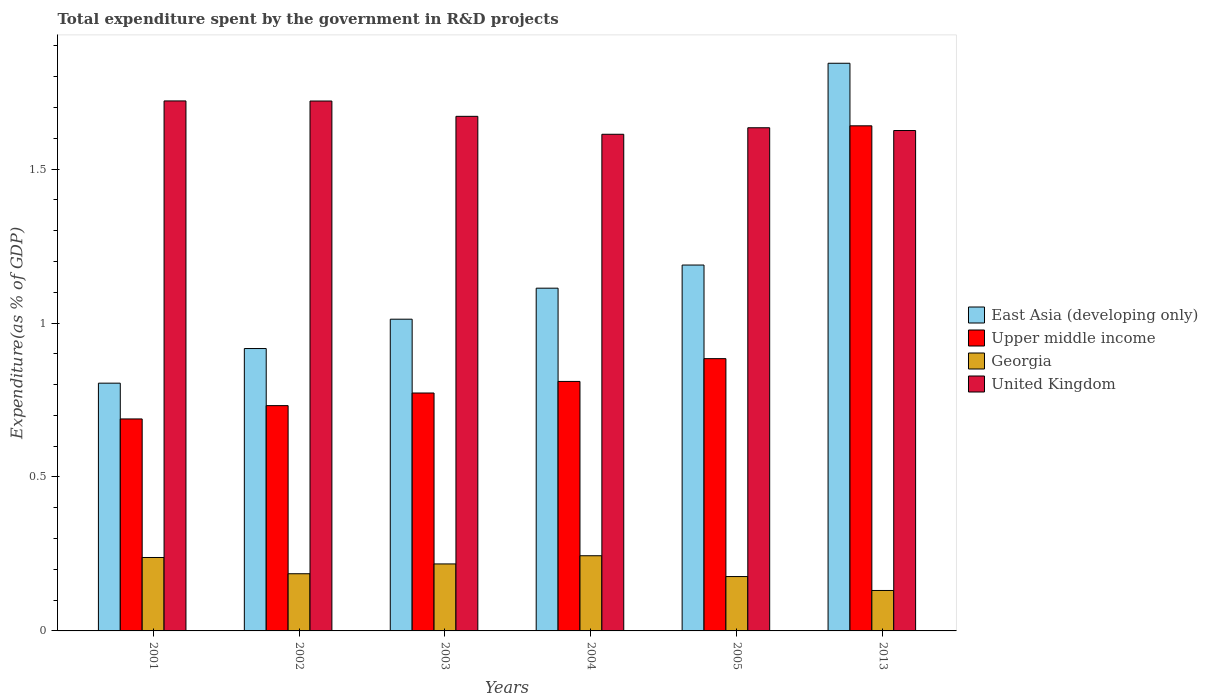How many different coloured bars are there?
Give a very brief answer. 4. How many groups of bars are there?
Keep it short and to the point. 6. Are the number of bars per tick equal to the number of legend labels?
Offer a terse response. Yes. Are the number of bars on each tick of the X-axis equal?
Provide a short and direct response. Yes. How many bars are there on the 4th tick from the left?
Provide a short and direct response. 4. How many bars are there on the 2nd tick from the right?
Offer a terse response. 4. What is the label of the 3rd group of bars from the left?
Your response must be concise. 2003. What is the total expenditure spent by the government in R&D projects in East Asia (developing only) in 2005?
Your response must be concise. 1.19. Across all years, what is the maximum total expenditure spent by the government in R&D projects in United Kingdom?
Your answer should be compact. 1.72. Across all years, what is the minimum total expenditure spent by the government in R&D projects in Upper middle income?
Offer a very short reply. 0.69. In which year was the total expenditure spent by the government in R&D projects in East Asia (developing only) minimum?
Your answer should be very brief. 2001. What is the total total expenditure spent by the government in R&D projects in East Asia (developing only) in the graph?
Offer a very short reply. 6.88. What is the difference between the total expenditure spent by the government in R&D projects in United Kingdom in 2003 and that in 2013?
Your answer should be compact. 0.05. What is the difference between the total expenditure spent by the government in R&D projects in Georgia in 2003 and the total expenditure spent by the government in R&D projects in United Kingdom in 2001?
Offer a very short reply. -1.5. What is the average total expenditure spent by the government in R&D projects in East Asia (developing only) per year?
Ensure brevity in your answer.  1.15. In the year 2004, what is the difference between the total expenditure spent by the government in R&D projects in United Kingdom and total expenditure spent by the government in R&D projects in East Asia (developing only)?
Offer a terse response. 0.5. In how many years, is the total expenditure spent by the government in R&D projects in Georgia greater than 1.4 %?
Ensure brevity in your answer.  0. What is the ratio of the total expenditure spent by the government in R&D projects in United Kingdom in 2003 to that in 2013?
Keep it short and to the point. 1.03. Is the total expenditure spent by the government in R&D projects in Upper middle income in 2001 less than that in 2003?
Offer a very short reply. Yes. What is the difference between the highest and the second highest total expenditure spent by the government in R&D projects in Georgia?
Provide a short and direct response. 0.01. What is the difference between the highest and the lowest total expenditure spent by the government in R&D projects in Upper middle income?
Make the answer very short. 0.95. In how many years, is the total expenditure spent by the government in R&D projects in Georgia greater than the average total expenditure spent by the government in R&D projects in Georgia taken over all years?
Provide a succinct answer. 3. What does the 2nd bar from the left in 2013 represents?
Your answer should be very brief. Upper middle income. What does the 4th bar from the right in 2013 represents?
Provide a succinct answer. East Asia (developing only). Is it the case that in every year, the sum of the total expenditure spent by the government in R&D projects in Georgia and total expenditure spent by the government in R&D projects in East Asia (developing only) is greater than the total expenditure spent by the government in R&D projects in United Kingdom?
Offer a terse response. No. How many bars are there?
Your answer should be compact. 24. Are all the bars in the graph horizontal?
Ensure brevity in your answer.  No. How many years are there in the graph?
Keep it short and to the point. 6. What is the difference between two consecutive major ticks on the Y-axis?
Offer a terse response. 0.5. Does the graph contain any zero values?
Provide a short and direct response. No. Does the graph contain grids?
Provide a succinct answer. No. How many legend labels are there?
Provide a short and direct response. 4. How are the legend labels stacked?
Your answer should be compact. Vertical. What is the title of the graph?
Your answer should be compact. Total expenditure spent by the government in R&D projects. Does "Tonga" appear as one of the legend labels in the graph?
Your response must be concise. No. What is the label or title of the Y-axis?
Provide a succinct answer. Expenditure(as % of GDP). What is the Expenditure(as % of GDP) of East Asia (developing only) in 2001?
Your response must be concise. 0.8. What is the Expenditure(as % of GDP) in Upper middle income in 2001?
Ensure brevity in your answer.  0.69. What is the Expenditure(as % of GDP) of Georgia in 2001?
Offer a very short reply. 0.24. What is the Expenditure(as % of GDP) of United Kingdom in 2001?
Give a very brief answer. 1.72. What is the Expenditure(as % of GDP) of East Asia (developing only) in 2002?
Give a very brief answer. 0.92. What is the Expenditure(as % of GDP) of Upper middle income in 2002?
Provide a succinct answer. 0.73. What is the Expenditure(as % of GDP) of Georgia in 2002?
Provide a short and direct response. 0.19. What is the Expenditure(as % of GDP) in United Kingdom in 2002?
Provide a succinct answer. 1.72. What is the Expenditure(as % of GDP) in East Asia (developing only) in 2003?
Offer a terse response. 1.01. What is the Expenditure(as % of GDP) in Upper middle income in 2003?
Offer a terse response. 0.77. What is the Expenditure(as % of GDP) of Georgia in 2003?
Your answer should be compact. 0.22. What is the Expenditure(as % of GDP) in United Kingdom in 2003?
Keep it short and to the point. 1.67. What is the Expenditure(as % of GDP) in East Asia (developing only) in 2004?
Keep it short and to the point. 1.11. What is the Expenditure(as % of GDP) in Upper middle income in 2004?
Your answer should be very brief. 0.81. What is the Expenditure(as % of GDP) of Georgia in 2004?
Provide a short and direct response. 0.24. What is the Expenditure(as % of GDP) of United Kingdom in 2004?
Keep it short and to the point. 1.61. What is the Expenditure(as % of GDP) of East Asia (developing only) in 2005?
Offer a very short reply. 1.19. What is the Expenditure(as % of GDP) of Upper middle income in 2005?
Provide a short and direct response. 0.88. What is the Expenditure(as % of GDP) of Georgia in 2005?
Ensure brevity in your answer.  0.18. What is the Expenditure(as % of GDP) in United Kingdom in 2005?
Keep it short and to the point. 1.63. What is the Expenditure(as % of GDP) in East Asia (developing only) in 2013?
Ensure brevity in your answer.  1.84. What is the Expenditure(as % of GDP) of Upper middle income in 2013?
Offer a terse response. 1.64. What is the Expenditure(as % of GDP) of Georgia in 2013?
Your answer should be very brief. 0.13. What is the Expenditure(as % of GDP) of United Kingdom in 2013?
Make the answer very short. 1.63. Across all years, what is the maximum Expenditure(as % of GDP) in East Asia (developing only)?
Your response must be concise. 1.84. Across all years, what is the maximum Expenditure(as % of GDP) of Upper middle income?
Provide a short and direct response. 1.64. Across all years, what is the maximum Expenditure(as % of GDP) in Georgia?
Your answer should be compact. 0.24. Across all years, what is the maximum Expenditure(as % of GDP) of United Kingdom?
Make the answer very short. 1.72. Across all years, what is the minimum Expenditure(as % of GDP) of East Asia (developing only)?
Provide a short and direct response. 0.8. Across all years, what is the minimum Expenditure(as % of GDP) of Upper middle income?
Your response must be concise. 0.69. Across all years, what is the minimum Expenditure(as % of GDP) of Georgia?
Make the answer very short. 0.13. Across all years, what is the minimum Expenditure(as % of GDP) of United Kingdom?
Your answer should be very brief. 1.61. What is the total Expenditure(as % of GDP) of East Asia (developing only) in the graph?
Provide a succinct answer. 6.88. What is the total Expenditure(as % of GDP) in Upper middle income in the graph?
Your answer should be compact. 5.53. What is the total Expenditure(as % of GDP) of Georgia in the graph?
Give a very brief answer. 1.19. What is the total Expenditure(as % of GDP) of United Kingdom in the graph?
Keep it short and to the point. 9.99. What is the difference between the Expenditure(as % of GDP) of East Asia (developing only) in 2001 and that in 2002?
Provide a short and direct response. -0.11. What is the difference between the Expenditure(as % of GDP) in Upper middle income in 2001 and that in 2002?
Offer a very short reply. -0.04. What is the difference between the Expenditure(as % of GDP) in Georgia in 2001 and that in 2002?
Offer a terse response. 0.05. What is the difference between the Expenditure(as % of GDP) of United Kingdom in 2001 and that in 2002?
Ensure brevity in your answer.  0. What is the difference between the Expenditure(as % of GDP) in East Asia (developing only) in 2001 and that in 2003?
Offer a very short reply. -0.21. What is the difference between the Expenditure(as % of GDP) in Upper middle income in 2001 and that in 2003?
Provide a succinct answer. -0.08. What is the difference between the Expenditure(as % of GDP) of Georgia in 2001 and that in 2003?
Offer a very short reply. 0.02. What is the difference between the Expenditure(as % of GDP) of East Asia (developing only) in 2001 and that in 2004?
Ensure brevity in your answer.  -0.31. What is the difference between the Expenditure(as % of GDP) in Upper middle income in 2001 and that in 2004?
Keep it short and to the point. -0.12. What is the difference between the Expenditure(as % of GDP) of Georgia in 2001 and that in 2004?
Your answer should be compact. -0.01. What is the difference between the Expenditure(as % of GDP) of United Kingdom in 2001 and that in 2004?
Offer a very short reply. 0.11. What is the difference between the Expenditure(as % of GDP) of East Asia (developing only) in 2001 and that in 2005?
Offer a very short reply. -0.38. What is the difference between the Expenditure(as % of GDP) of Upper middle income in 2001 and that in 2005?
Offer a terse response. -0.2. What is the difference between the Expenditure(as % of GDP) in Georgia in 2001 and that in 2005?
Ensure brevity in your answer.  0.06. What is the difference between the Expenditure(as % of GDP) of United Kingdom in 2001 and that in 2005?
Provide a short and direct response. 0.09. What is the difference between the Expenditure(as % of GDP) in East Asia (developing only) in 2001 and that in 2013?
Offer a very short reply. -1.04. What is the difference between the Expenditure(as % of GDP) of Upper middle income in 2001 and that in 2013?
Offer a very short reply. -0.95. What is the difference between the Expenditure(as % of GDP) in Georgia in 2001 and that in 2013?
Provide a short and direct response. 0.11. What is the difference between the Expenditure(as % of GDP) in United Kingdom in 2001 and that in 2013?
Offer a terse response. 0.1. What is the difference between the Expenditure(as % of GDP) of East Asia (developing only) in 2002 and that in 2003?
Keep it short and to the point. -0.1. What is the difference between the Expenditure(as % of GDP) in Upper middle income in 2002 and that in 2003?
Your answer should be very brief. -0.04. What is the difference between the Expenditure(as % of GDP) of Georgia in 2002 and that in 2003?
Provide a short and direct response. -0.03. What is the difference between the Expenditure(as % of GDP) in United Kingdom in 2002 and that in 2003?
Ensure brevity in your answer.  0.05. What is the difference between the Expenditure(as % of GDP) in East Asia (developing only) in 2002 and that in 2004?
Your answer should be very brief. -0.2. What is the difference between the Expenditure(as % of GDP) in Upper middle income in 2002 and that in 2004?
Your answer should be very brief. -0.08. What is the difference between the Expenditure(as % of GDP) of Georgia in 2002 and that in 2004?
Offer a terse response. -0.06. What is the difference between the Expenditure(as % of GDP) in United Kingdom in 2002 and that in 2004?
Your response must be concise. 0.11. What is the difference between the Expenditure(as % of GDP) of East Asia (developing only) in 2002 and that in 2005?
Offer a very short reply. -0.27. What is the difference between the Expenditure(as % of GDP) of Upper middle income in 2002 and that in 2005?
Provide a short and direct response. -0.15. What is the difference between the Expenditure(as % of GDP) of Georgia in 2002 and that in 2005?
Make the answer very short. 0.01. What is the difference between the Expenditure(as % of GDP) of United Kingdom in 2002 and that in 2005?
Offer a very short reply. 0.09. What is the difference between the Expenditure(as % of GDP) of East Asia (developing only) in 2002 and that in 2013?
Give a very brief answer. -0.93. What is the difference between the Expenditure(as % of GDP) of Upper middle income in 2002 and that in 2013?
Offer a very short reply. -0.91. What is the difference between the Expenditure(as % of GDP) in Georgia in 2002 and that in 2013?
Keep it short and to the point. 0.05. What is the difference between the Expenditure(as % of GDP) of United Kingdom in 2002 and that in 2013?
Make the answer very short. 0.1. What is the difference between the Expenditure(as % of GDP) of East Asia (developing only) in 2003 and that in 2004?
Your answer should be compact. -0.1. What is the difference between the Expenditure(as % of GDP) in Upper middle income in 2003 and that in 2004?
Your response must be concise. -0.04. What is the difference between the Expenditure(as % of GDP) in Georgia in 2003 and that in 2004?
Give a very brief answer. -0.03. What is the difference between the Expenditure(as % of GDP) in United Kingdom in 2003 and that in 2004?
Provide a succinct answer. 0.06. What is the difference between the Expenditure(as % of GDP) in East Asia (developing only) in 2003 and that in 2005?
Offer a terse response. -0.18. What is the difference between the Expenditure(as % of GDP) of Upper middle income in 2003 and that in 2005?
Offer a terse response. -0.11. What is the difference between the Expenditure(as % of GDP) in Georgia in 2003 and that in 2005?
Your answer should be very brief. 0.04. What is the difference between the Expenditure(as % of GDP) in United Kingdom in 2003 and that in 2005?
Your answer should be very brief. 0.04. What is the difference between the Expenditure(as % of GDP) of East Asia (developing only) in 2003 and that in 2013?
Offer a very short reply. -0.83. What is the difference between the Expenditure(as % of GDP) in Upper middle income in 2003 and that in 2013?
Provide a succinct answer. -0.87. What is the difference between the Expenditure(as % of GDP) in Georgia in 2003 and that in 2013?
Your response must be concise. 0.09. What is the difference between the Expenditure(as % of GDP) of United Kingdom in 2003 and that in 2013?
Give a very brief answer. 0.05. What is the difference between the Expenditure(as % of GDP) in East Asia (developing only) in 2004 and that in 2005?
Provide a succinct answer. -0.08. What is the difference between the Expenditure(as % of GDP) in Upper middle income in 2004 and that in 2005?
Offer a terse response. -0.07. What is the difference between the Expenditure(as % of GDP) in Georgia in 2004 and that in 2005?
Keep it short and to the point. 0.07. What is the difference between the Expenditure(as % of GDP) in United Kingdom in 2004 and that in 2005?
Offer a terse response. -0.02. What is the difference between the Expenditure(as % of GDP) in East Asia (developing only) in 2004 and that in 2013?
Ensure brevity in your answer.  -0.73. What is the difference between the Expenditure(as % of GDP) of Upper middle income in 2004 and that in 2013?
Your answer should be compact. -0.83. What is the difference between the Expenditure(as % of GDP) of Georgia in 2004 and that in 2013?
Offer a terse response. 0.11. What is the difference between the Expenditure(as % of GDP) in United Kingdom in 2004 and that in 2013?
Keep it short and to the point. -0.01. What is the difference between the Expenditure(as % of GDP) of East Asia (developing only) in 2005 and that in 2013?
Provide a short and direct response. -0.66. What is the difference between the Expenditure(as % of GDP) of Upper middle income in 2005 and that in 2013?
Provide a succinct answer. -0.76. What is the difference between the Expenditure(as % of GDP) of Georgia in 2005 and that in 2013?
Offer a terse response. 0.05. What is the difference between the Expenditure(as % of GDP) of United Kingdom in 2005 and that in 2013?
Keep it short and to the point. 0.01. What is the difference between the Expenditure(as % of GDP) of East Asia (developing only) in 2001 and the Expenditure(as % of GDP) of Upper middle income in 2002?
Your answer should be very brief. 0.07. What is the difference between the Expenditure(as % of GDP) in East Asia (developing only) in 2001 and the Expenditure(as % of GDP) in Georgia in 2002?
Offer a terse response. 0.62. What is the difference between the Expenditure(as % of GDP) in East Asia (developing only) in 2001 and the Expenditure(as % of GDP) in United Kingdom in 2002?
Make the answer very short. -0.92. What is the difference between the Expenditure(as % of GDP) in Upper middle income in 2001 and the Expenditure(as % of GDP) in Georgia in 2002?
Provide a succinct answer. 0.5. What is the difference between the Expenditure(as % of GDP) of Upper middle income in 2001 and the Expenditure(as % of GDP) of United Kingdom in 2002?
Your response must be concise. -1.03. What is the difference between the Expenditure(as % of GDP) in Georgia in 2001 and the Expenditure(as % of GDP) in United Kingdom in 2002?
Keep it short and to the point. -1.48. What is the difference between the Expenditure(as % of GDP) of East Asia (developing only) in 2001 and the Expenditure(as % of GDP) of Upper middle income in 2003?
Offer a terse response. 0.03. What is the difference between the Expenditure(as % of GDP) in East Asia (developing only) in 2001 and the Expenditure(as % of GDP) in Georgia in 2003?
Your answer should be compact. 0.59. What is the difference between the Expenditure(as % of GDP) of East Asia (developing only) in 2001 and the Expenditure(as % of GDP) of United Kingdom in 2003?
Ensure brevity in your answer.  -0.87. What is the difference between the Expenditure(as % of GDP) of Upper middle income in 2001 and the Expenditure(as % of GDP) of Georgia in 2003?
Your answer should be very brief. 0.47. What is the difference between the Expenditure(as % of GDP) of Upper middle income in 2001 and the Expenditure(as % of GDP) of United Kingdom in 2003?
Make the answer very short. -0.98. What is the difference between the Expenditure(as % of GDP) in Georgia in 2001 and the Expenditure(as % of GDP) in United Kingdom in 2003?
Make the answer very short. -1.43. What is the difference between the Expenditure(as % of GDP) of East Asia (developing only) in 2001 and the Expenditure(as % of GDP) of Upper middle income in 2004?
Provide a succinct answer. -0.01. What is the difference between the Expenditure(as % of GDP) in East Asia (developing only) in 2001 and the Expenditure(as % of GDP) in Georgia in 2004?
Keep it short and to the point. 0.56. What is the difference between the Expenditure(as % of GDP) in East Asia (developing only) in 2001 and the Expenditure(as % of GDP) in United Kingdom in 2004?
Your response must be concise. -0.81. What is the difference between the Expenditure(as % of GDP) in Upper middle income in 2001 and the Expenditure(as % of GDP) in Georgia in 2004?
Your response must be concise. 0.44. What is the difference between the Expenditure(as % of GDP) of Upper middle income in 2001 and the Expenditure(as % of GDP) of United Kingdom in 2004?
Your answer should be very brief. -0.92. What is the difference between the Expenditure(as % of GDP) in Georgia in 2001 and the Expenditure(as % of GDP) in United Kingdom in 2004?
Offer a terse response. -1.37. What is the difference between the Expenditure(as % of GDP) in East Asia (developing only) in 2001 and the Expenditure(as % of GDP) in Upper middle income in 2005?
Provide a short and direct response. -0.08. What is the difference between the Expenditure(as % of GDP) in East Asia (developing only) in 2001 and the Expenditure(as % of GDP) in Georgia in 2005?
Give a very brief answer. 0.63. What is the difference between the Expenditure(as % of GDP) in East Asia (developing only) in 2001 and the Expenditure(as % of GDP) in United Kingdom in 2005?
Keep it short and to the point. -0.83. What is the difference between the Expenditure(as % of GDP) in Upper middle income in 2001 and the Expenditure(as % of GDP) in Georgia in 2005?
Provide a succinct answer. 0.51. What is the difference between the Expenditure(as % of GDP) in Upper middle income in 2001 and the Expenditure(as % of GDP) in United Kingdom in 2005?
Your answer should be compact. -0.95. What is the difference between the Expenditure(as % of GDP) of Georgia in 2001 and the Expenditure(as % of GDP) of United Kingdom in 2005?
Your answer should be very brief. -1.4. What is the difference between the Expenditure(as % of GDP) in East Asia (developing only) in 2001 and the Expenditure(as % of GDP) in Upper middle income in 2013?
Your answer should be very brief. -0.84. What is the difference between the Expenditure(as % of GDP) in East Asia (developing only) in 2001 and the Expenditure(as % of GDP) in Georgia in 2013?
Ensure brevity in your answer.  0.67. What is the difference between the Expenditure(as % of GDP) of East Asia (developing only) in 2001 and the Expenditure(as % of GDP) of United Kingdom in 2013?
Provide a short and direct response. -0.82. What is the difference between the Expenditure(as % of GDP) of Upper middle income in 2001 and the Expenditure(as % of GDP) of Georgia in 2013?
Ensure brevity in your answer.  0.56. What is the difference between the Expenditure(as % of GDP) in Upper middle income in 2001 and the Expenditure(as % of GDP) in United Kingdom in 2013?
Your answer should be very brief. -0.94. What is the difference between the Expenditure(as % of GDP) of Georgia in 2001 and the Expenditure(as % of GDP) of United Kingdom in 2013?
Offer a terse response. -1.39. What is the difference between the Expenditure(as % of GDP) of East Asia (developing only) in 2002 and the Expenditure(as % of GDP) of Upper middle income in 2003?
Offer a very short reply. 0.14. What is the difference between the Expenditure(as % of GDP) of East Asia (developing only) in 2002 and the Expenditure(as % of GDP) of Georgia in 2003?
Give a very brief answer. 0.7. What is the difference between the Expenditure(as % of GDP) of East Asia (developing only) in 2002 and the Expenditure(as % of GDP) of United Kingdom in 2003?
Give a very brief answer. -0.75. What is the difference between the Expenditure(as % of GDP) of Upper middle income in 2002 and the Expenditure(as % of GDP) of Georgia in 2003?
Offer a terse response. 0.51. What is the difference between the Expenditure(as % of GDP) of Upper middle income in 2002 and the Expenditure(as % of GDP) of United Kingdom in 2003?
Offer a very short reply. -0.94. What is the difference between the Expenditure(as % of GDP) in Georgia in 2002 and the Expenditure(as % of GDP) in United Kingdom in 2003?
Your answer should be compact. -1.49. What is the difference between the Expenditure(as % of GDP) in East Asia (developing only) in 2002 and the Expenditure(as % of GDP) in Upper middle income in 2004?
Keep it short and to the point. 0.11. What is the difference between the Expenditure(as % of GDP) in East Asia (developing only) in 2002 and the Expenditure(as % of GDP) in Georgia in 2004?
Your answer should be compact. 0.67. What is the difference between the Expenditure(as % of GDP) in East Asia (developing only) in 2002 and the Expenditure(as % of GDP) in United Kingdom in 2004?
Give a very brief answer. -0.7. What is the difference between the Expenditure(as % of GDP) in Upper middle income in 2002 and the Expenditure(as % of GDP) in Georgia in 2004?
Offer a very short reply. 0.49. What is the difference between the Expenditure(as % of GDP) of Upper middle income in 2002 and the Expenditure(as % of GDP) of United Kingdom in 2004?
Offer a very short reply. -0.88. What is the difference between the Expenditure(as % of GDP) in Georgia in 2002 and the Expenditure(as % of GDP) in United Kingdom in 2004?
Your answer should be compact. -1.43. What is the difference between the Expenditure(as % of GDP) in East Asia (developing only) in 2002 and the Expenditure(as % of GDP) in Upper middle income in 2005?
Make the answer very short. 0.03. What is the difference between the Expenditure(as % of GDP) in East Asia (developing only) in 2002 and the Expenditure(as % of GDP) in Georgia in 2005?
Keep it short and to the point. 0.74. What is the difference between the Expenditure(as % of GDP) in East Asia (developing only) in 2002 and the Expenditure(as % of GDP) in United Kingdom in 2005?
Provide a succinct answer. -0.72. What is the difference between the Expenditure(as % of GDP) in Upper middle income in 2002 and the Expenditure(as % of GDP) in Georgia in 2005?
Provide a succinct answer. 0.56. What is the difference between the Expenditure(as % of GDP) in Upper middle income in 2002 and the Expenditure(as % of GDP) in United Kingdom in 2005?
Keep it short and to the point. -0.9. What is the difference between the Expenditure(as % of GDP) in Georgia in 2002 and the Expenditure(as % of GDP) in United Kingdom in 2005?
Your response must be concise. -1.45. What is the difference between the Expenditure(as % of GDP) of East Asia (developing only) in 2002 and the Expenditure(as % of GDP) of Upper middle income in 2013?
Make the answer very short. -0.72. What is the difference between the Expenditure(as % of GDP) in East Asia (developing only) in 2002 and the Expenditure(as % of GDP) in Georgia in 2013?
Make the answer very short. 0.79. What is the difference between the Expenditure(as % of GDP) in East Asia (developing only) in 2002 and the Expenditure(as % of GDP) in United Kingdom in 2013?
Provide a short and direct response. -0.71. What is the difference between the Expenditure(as % of GDP) in Upper middle income in 2002 and the Expenditure(as % of GDP) in Georgia in 2013?
Your answer should be compact. 0.6. What is the difference between the Expenditure(as % of GDP) of Upper middle income in 2002 and the Expenditure(as % of GDP) of United Kingdom in 2013?
Offer a terse response. -0.89. What is the difference between the Expenditure(as % of GDP) in Georgia in 2002 and the Expenditure(as % of GDP) in United Kingdom in 2013?
Make the answer very short. -1.44. What is the difference between the Expenditure(as % of GDP) of East Asia (developing only) in 2003 and the Expenditure(as % of GDP) of Upper middle income in 2004?
Give a very brief answer. 0.2. What is the difference between the Expenditure(as % of GDP) in East Asia (developing only) in 2003 and the Expenditure(as % of GDP) in Georgia in 2004?
Offer a terse response. 0.77. What is the difference between the Expenditure(as % of GDP) of East Asia (developing only) in 2003 and the Expenditure(as % of GDP) of United Kingdom in 2004?
Keep it short and to the point. -0.6. What is the difference between the Expenditure(as % of GDP) of Upper middle income in 2003 and the Expenditure(as % of GDP) of Georgia in 2004?
Offer a very short reply. 0.53. What is the difference between the Expenditure(as % of GDP) of Upper middle income in 2003 and the Expenditure(as % of GDP) of United Kingdom in 2004?
Offer a very short reply. -0.84. What is the difference between the Expenditure(as % of GDP) in Georgia in 2003 and the Expenditure(as % of GDP) in United Kingdom in 2004?
Your answer should be compact. -1.4. What is the difference between the Expenditure(as % of GDP) in East Asia (developing only) in 2003 and the Expenditure(as % of GDP) in Upper middle income in 2005?
Provide a succinct answer. 0.13. What is the difference between the Expenditure(as % of GDP) in East Asia (developing only) in 2003 and the Expenditure(as % of GDP) in Georgia in 2005?
Keep it short and to the point. 0.84. What is the difference between the Expenditure(as % of GDP) in East Asia (developing only) in 2003 and the Expenditure(as % of GDP) in United Kingdom in 2005?
Offer a very short reply. -0.62. What is the difference between the Expenditure(as % of GDP) in Upper middle income in 2003 and the Expenditure(as % of GDP) in Georgia in 2005?
Offer a terse response. 0.6. What is the difference between the Expenditure(as % of GDP) of Upper middle income in 2003 and the Expenditure(as % of GDP) of United Kingdom in 2005?
Ensure brevity in your answer.  -0.86. What is the difference between the Expenditure(as % of GDP) of Georgia in 2003 and the Expenditure(as % of GDP) of United Kingdom in 2005?
Make the answer very short. -1.42. What is the difference between the Expenditure(as % of GDP) of East Asia (developing only) in 2003 and the Expenditure(as % of GDP) of Upper middle income in 2013?
Provide a short and direct response. -0.63. What is the difference between the Expenditure(as % of GDP) in East Asia (developing only) in 2003 and the Expenditure(as % of GDP) in Georgia in 2013?
Provide a short and direct response. 0.88. What is the difference between the Expenditure(as % of GDP) of East Asia (developing only) in 2003 and the Expenditure(as % of GDP) of United Kingdom in 2013?
Provide a short and direct response. -0.61. What is the difference between the Expenditure(as % of GDP) of Upper middle income in 2003 and the Expenditure(as % of GDP) of Georgia in 2013?
Keep it short and to the point. 0.64. What is the difference between the Expenditure(as % of GDP) of Upper middle income in 2003 and the Expenditure(as % of GDP) of United Kingdom in 2013?
Give a very brief answer. -0.85. What is the difference between the Expenditure(as % of GDP) of Georgia in 2003 and the Expenditure(as % of GDP) of United Kingdom in 2013?
Offer a very short reply. -1.41. What is the difference between the Expenditure(as % of GDP) of East Asia (developing only) in 2004 and the Expenditure(as % of GDP) of Upper middle income in 2005?
Your answer should be very brief. 0.23. What is the difference between the Expenditure(as % of GDP) of East Asia (developing only) in 2004 and the Expenditure(as % of GDP) of Georgia in 2005?
Provide a succinct answer. 0.94. What is the difference between the Expenditure(as % of GDP) of East Asia (developing only) in 2004 and the Expenditure(as % of GDP) of United Kingdom in 2005?
Give a very brief answer. -0.52. What is the difference between the Expenditure(as % of GDP) in Upper middle income in 2004 and the Expenditure(as % of GDP) in Georgia in 2005?
Make the answer very short. 0.63. What is the difference between the Expenditure(as % of GDP) of Upper middle income in 2004 and the Expenditure(as % of GDP) of United Kingdom in 2005?
Offer a very short reply. -0.82. What is the difference between the Expenditure(as % of GDP) of Georgia in 2004 and the Expenditure(as % of GDP) of United Kingdom in 2005?
Provide a short and direct response. -1.39. What is the difference between the Expenditure(as % of GDP) in East Asia (developing only) in 2004 and the Expenditure(as % of GDP) in Upper middle income in 2013?
Your answer should be compact. -0.53. What is the difference between the Expenditure(as % of GDP) of East Asia (developing only) in 2004 and the Expenditure(as % of GDP) of Georgia in 2013?
Provide a short and direct response. 0.98. What is the difference between the Expenditure(as % of GDP) in East Asia (developing only) in 2004 and the Expenditure(as % of GDP) in United Kingdom in 2013?
Offer a terse response. -0.51. What is the difference between the Expenditure(as % of GDP) in Upper middle income in 2004 and the Expenditure(as % of GDP) in Georgia in 2013?
Provide a succinct answer. 0.68. What is the difference between the Expenditure(as % of GDP) of Upper middle income in 2004 and the Expenditure(as % of GDP) of United Kingdom in 2013?
Your answer should be compact. -0.81. What is the difference between the Expenditure(as % of GDP) of Georgia in 2004 and the Expenditure(as % of GDP) of United Kingdom in 2013?
Offer a terse response. -1.38. What is the difference between the Expenditure(as % of GDP) of East Asia (developing only) in 2005 and the Expenditure(as % of GDP) of Upper middle income in 2013?
Offer a terse response. -0.45. What is the difference between the Expenditure(as % of GDP) in East Asia (developing only) in 2005 and the Expenditure(as % of GDP) in Georgia in 2013?
Offer a terse response. 1.06. What is the difference between the Expenditure(as % of GDP) of East Asia (developing only) in 2005 and the Expenditure(as % of GDP) of United Kingdom in 2013?
Offer a very short reply. -0.44. What is the difference between the Expenditure(as % of GDP) in Upper middle income in 2005 and the Expenditure(as % of GDP) in Georgia in 2013?
Ensure brevity in your answer.  0.75. What is the difference between the Expenditure(as % of GDP) of Upper middle income in 2005 and the Expenditure(as % of GDP) of United Kingdom in 2013?
Provide a succinct answer. -0.74. What is the difference between the Expenditure(as % of GDP) of Georgia in 2005 and the Expenditure(as % of GDP) of United Kingdom in 2013?
Your response must be concise. -1.45. What is the average Expenditure(as % of GDP) in East Asia (developing only) per year?
Your answer should be compact. 1.15. What is the average Expenditure(as % of GDP) of Upper middle income per year?
Offer a very short reply. 0.92. What is the average Expenditure(as % of GDP) in Georgia per year?
Ensure brevity in your answer.  0.2. What is the average Expenditure(as % of GDP) in United Kingdom per year?
Keep it short and to the point. 1.66. In the year 2001, what is the difference between the Expenditure(as % of GDP) in East Asia (developing only) and Expenditure(as % of GDP) in Upper middle income?
Provide a short and direct response. 0.12. In the year 2001, what is the difference between the Expenditure(as % of GDP) of East Asia (developing only) and Expenditure(as % of GDP) of Georgia?
Make the answer very short. 0.57. In the year 2001, what is the difference between the Expenditure(as % of GDP) of East Asia (developing only) and Expenditure(as % of GDP) of United Kingdom?
Offer a terse response. -0.92. In the year 2001, what is the difference between the Expenditure(as % of GDP) in Upper middle income and Expenditure(as % of GDP) in Georgia?
Your answer should be compact. 0.45. In the year 2001, what is the difference between the Expenditure(as % of GDP) in Upper middle income and Expenditure(as % of GDP) in United Kingdom?
Offer a terse response. -1.03. In the year 2001, what is the difference between the Expenditure(as % of GDP) in Georgia and Expenditure(as % of GDP) in United Kingdom?
Offer a terse response. -1.48. In the year 2002, what is the difference between the Expenditure(as % of GDP) of East Asia (developing only) and Expenditure(as % of GDP) of Upper middle income?
Your answer should be compact. 0.19. In the year 2002, what is the difference between the Expenditure(as % of GDP) of East Asia (developing only) and Expenditure(as % of GDP) of Georgia?
Provide a short and direct response. 0.73. In the year 2002, what is the difference between the Expenditure(as % of GDP) in East Asia (developing only) and Expenditure(as % of GDP) in United Kingdom?
Your answer should be compact. -0.8. In the year 2002, what is the difference between the Expenditure(as % of GDP) in Upper middle income and Expenditure(as % of GDP) in Georgia?
Offer a terse response. 0.55. In the year 2002, what is the difference between the Expenditure(as % of GDP) in Upper middle income and Expenditure(as % of GDP) in United Kingdom?
Provide a succinct answer. -0.99. In the year 2002, what is the difference between the Expenditure(as % of GDP) of Georgia and Expenditure(as % of GDP) of United Kingdom?
Offer a terse response. -1.54. In the year 2003, what is the difference between the Expenditure(as % of GDP) in East Asia (developing only) and Expenditure(as % of GDP) in Upper middle income?
Make the answer very short. 0.24. In the year 2003, what is the difference between the Expenditure(as % of GDP) of East Asia (developing only) and Expenditure(as % of GDP) of Georgia?
Offer a very short reply. 0.79. In the year 2003, what is the difference between the Expenditure(as % of GDP) in East Asia (developing only) and Expenditure(as % of GDP) in United Kingdom?
Offer a terse response. -0.66. In the year 2003, what is the difference between the Expenditure(as % of GDP) in Upper middle income and Expenditure(as % of GDP) in Georgia?
Your answer should be very brief. 0.56. In the year 2003, what is the difference between the Expenditure(as % of GDP) in Upper middle income and Expenditure(as % of GDP) in United Kingdom?
Offer a very short reply. -0.9. In the year 2003, what is the difference between the Expenditure(as % of GDP) in Georgia and Expenditure(as % of GDP) in United Kingdom?
Your answer should be very brief. -1.45. In the year 2004, what is the difference between the Expenditure(as % of GDP) of East Asia (developing only) and Expenditure(as % of GDP) of Upper middle income?
Make the answer very short. 0.3. In the year 2004, what is the difference between the Expenditure(as % of GDP) in East Asia (developing only) and Expenditure(as % of GDP) in Georgia?
Keep it short and to the point. 0.87. In the year 2004, what is the difference between the Expenditure(as % of GDP) in East Asia (developing only) and Expenditure(as % of GDP) in United Kingdom?
Provide a succinct answer. -0.5. In the year 2004, what is the difference between the Expenditure(as % of GDP) of Upper middle income and Expenditure(as % of GDP) of Georgia?
Offer a very short reply. 0.57. In the year 2004, what is the difference between the Expenditure(as % of GDP) in Upper middle income and Expenditure(as % of GDP) in United Kingdom?
Provide a short and direct response. -0.8. In the year 2004, what is the difference between the Expenditure(as % of GDP) in Georgia and Expenditure(as % of GDP) in United Kingdom?
Provide a short and direct response. -1.37. In the year 2005, what is the difference between the Expenditure(as % of GDP) of East Asia (developing only) and Expenditure(as % of GDP) of Upper middle income?
Make the answer very short. 0.3. In the year 2005, what is the difference between the Expenditure(as % of GDP) of East Asia (developing only) and Expenditure(as % of GDP) of Georgia?
Your answer should be very brief. 1.01. In the year 2005, what is the difference between the Expenditure(as % of GDP) in East Asia (developing only) and Expenditure(as % of GDP) in United Kingdom?
Give a very brief answer. -0.45. In the year 2005, what is the difference between the Expenditure(as % of GDP) of Upper middle income and Expenditure(as % of GDP) of Georgia?
Keep it short and to the point. 0.71. In the year 2005, what is the difference between the Expenditure(as % of GDP) of Upper middle income and Expenditure(as % of GDP) of United Kingdom?
Provide a succinct answer. -0.75. In the year 2005, what is the difference between the Expenditure(as % of GDP) of Georgia and Expenditure(as % of GDP) of United Kingdom?
Give a very brief answer. -1.46. In the year 2013, what is the difference between the Expenditure(as % of GDP) of East Asia (developing only) and Expenditure(as % of GDP) of Upper middle income?
Ensure brevity in your answer.  0.2. In the year 2013, what is the difference between the Expenditure(as % of GDP) of East Asia (developing only) and Expenditure(as % of GDP) of Georgia?
Provide a short and direct response. 1.71. In the year 2013, what is the difference between the Expenditure(as % of GDP) of East Asia (developing only) and Expenditure(as % of GDP) of United Kingdom?
Keep it short and to the point. 0.22. In the year 2013, what is the difference between the Expenditure(as % of GDP) in Upper middle income and Expenditure(as % of GDP) in Georgia?
Provide a short and direct response. 1.51. In the year 2013, what is the difference between the Expenditure(as % of GDP) of Upper middle income and Expenditure(as % of GDP) of United Kingdom?
Offer a very short reply. 0.02. In the year 2013, what is the difference between the Expenditure(as % of GDP) of Georgia and Expenditure(as % of GDP) of United Kingdom?
Your answer should be compact. -1.49. What is the ratio of the Expenditure(as % of GDP) in East Asia (developing only) in 2001 to that in 2002?
Offer a very short reply. 0.88. What is the ratio of the Expenditure(as % of GDP) of Upper middle income in 2001 to that in 2002?
Ensure brevity in your answer.  0.94. What is the ratio of the Expenditure(as % of GDP) in Georgia in 2001 to that in 2002?
Provide a short and direct response. 1.28. What is the ratio of the Expenditure(as % of GDP) of East Asia (developing only) in 2001 to that in 2003?
Your answer should be very brief. 0.79. What is the ratio of the Expenditure(as % of GDP) of Upper middle income in 2001 to that in 2003?
Your answer should be compact. 0.89. What is the ratio of the Expenditure(as % of GDP) of Georgia in 2001 to that in 2003?
Keep it short and to the point. 1.1. What is the ratio of the Expenditure(as % of GDP) in United Kingdom in 2001 to that in 2003?
Provide a succinct answer. 1.03. What is the ratio of the Expenditure(as % of GDP) of East Asia (developing only) in 2001 to that in 2004?
Your answer should be compact. 0.72. What is the ratio of the Expenditure(as % of GDP) in Upper middle income in 2001 to that in 2004?
Provide a short and direct response. 0.85. What is the ratio of the Expenditure(as % of GDP) in Georgia in 2001 to that in 2004?
Your response must be concise. 0.98. What is the ratio of the Expenditure(as % of GDP) in United Kingdom in 2001 to that in 2004?
Make the answer very short. 1.07. What is the ratio of the Expenditure(as % of GDP) of East Asia (developing only) in 2001 to that in 2005?
Give a very brief answer. 0.68. What is the ratio of the Expenditure(as % of GDP) in Upper middle income in 2001 to that in 2005?
Keep it short and to the point. 0.78. What is the ratio of the Expenditure(as % of GDP) of Georgia in 2001 to that in 2005?
Your answer should be very brief. 1.35. What is the ratio of the Expenditure(as % of GDP) in United Kingdom in 2001 to that in 2005?
Keep it short and to the point. 1.05. What is the ratio of the Expenditure(as % of GDP) in East Asia (developing only) in 2001 to that in 2013?
Make the answer very short. 0.44. What is the ratio of the Expenditure(as % of GDP) in Upper middle income in 2001 to that in 2013?
Your answer should be very brief. 0.42. What is the ratio of the Expenditure(as % of GDP) in Georgia in 2001 to that in 2013?
Give a very brief answer. 1.82. What is the ratio of the Expenditure(as % of GDP) in United Kingdom in 2001 to that in 2013?
Keep it short and to the point. 1.06. What is the ratio of the Expenditure(as % of GDP) in East Asia (developing only) in 2002 to that in 2003?
Your answer should be compact. 0.91. What is the ratio of the Expenditure(as % of GDP) of Upper middle income in 2002 to that in 2003?
Your response must be concise. 0.95. What is the ratio of the Expenditure(as % of GDP) of Georgia in 2002 to that in 2003?
Offer a very short reply. 0.85. What is the ratio of the Expenditure(as % of GDP) in United Kingdom in 2002 to that in 2003?
Make the answer very short. 1.03. What is the ratio of the Expenditure(as % of GDP) of East Asia (developing only) in 2002 to that in 2004?
Make the answer very short. 0.82. What is the ratio of the Expenditure(as % of GDP) of Upper middle income in 2002 to that in 2004?
Give a very brief answer. 0.9. What is the ratio of the Expenditure(as % of GDP) in Georgia in 2002 to that in 2004?
Make the answer very short. 0.76. What is the ratio of the Expenditure(as % of GDP) of United Kingdom in 2002 to that in 2004?
Give a very brief answer. 1.07. What is the ratio of the Expenditure(as % of GDP) in East Asia (developing only) in 2002 to that in 2005?
Provide a short and direct response. 0.77. What is the ratio of the Expenditure(as % of GDP) of Upper middle income in 2002 to that in 2005?
Ensure brevity in your answer.  0.83. What is the ratio of the Expenditure(as % of GDP) of Georgia in 2002 to that in 2005?
Give a very brief answer. 1.05. What is the ratio of the Expenditure(as % of GDP) of United Kingdom in 2002 to that in 2005?
Ensure brevity in your answer.  1.05. What is the ratio of the Expenditure(as % of GDP) of East Asia (developing only) in 2002 to that in 2013?
Offer a very short reply. 0.5. What is the ratio of the Expenditure(as % of GDP) of Upper middle income in 2002 to that in 2013?
Provide a succinct answer. 0.45. What is the ratio of the Expenditure(as % of GDP) in Georgia in 2002 to that in 2013?
Provide a succinct answer. 1.41. What is the ratio of the Expenditure(as % of GDP) of United Kingdom in 2002 to that in 2013?
Your answer should be very brief. 1.06. What is the ratio of the Expenditure(as % of GDP) in East Asia (developing only) in 2003 to that in 2004?
Make the answer very short. 0.91. What is the ratio of the Expenditure(as % of GDP) of Upper middle income in 2003 to that in 2004?
Ensure brevity in your answer.  0.95. What is the ratio of the Expenditure(as % of GDP) of Georgia in 2003 to that in 2004?
Keep it short and to the point. 0.89. What is the ratio of the Expenditure(as % of GDP) of United Kingdom in 2003 to that in 2004?
Your answer should be compact. 1.04. What is the ratio of the Expenditure(as % of GDP) of East Asia (developing only) in 2003 to that in 2005?
Offer a very short reply. 0.85. What is the ratio of the Expenditure(as % of GDP) in Upper middle income in 2003 to that in 2005?
Ensure brevity in your answer.  0.87. What is the ratio of the Expenditure(as % of GDP) in Georgia in 2003 to that in 2005?
Keep it short and to the point. 1.23. What is the ratio of the Expenditure(as % of GDP) in United Kingdom in 2003 to that in 2005?
Your response must be concise. 1.02. What is the ratio of the Expenditure(as % of GDP) in East Asia (developing only) in 2003 to that in 2013?
Give a very brief answer. 0.55. What is the ratio of the Expenditure(as % of GDP) of Upper middle income in 2003 to that in 2013?
Your answer should be compact. 0.47. What is the ratio of the Expenditure(as % of GDP) of Georgia in 2003 to that in 2013?
Keep it short and to the point. 1.66. What is the ratio of the Expenditure(as % of GDP) of United Kingdom in 2003 to that in 2013?
Offer a terse response. 1.03. What is the ratio of the Expenditure(as % of GDP) of East Asia (developing only) in 2004 to that in 2005?
Keep it short and to the point. 0.94. What is the ratio of the Expenditure(as % of GDP) in Upper middle income in 2004 to that in 2005?
Offer a terse response. 0.92. What is the ratio of the Expenditure(as % of GDP) of Georgia in 2004 to that in 2005?
Your answer should be compact. 1.38. What is the ratio of the Expenditure(as % of GDP) of United Kingdom in 2004 to that in 2005?
Your response must be concise. 0.99. What is the ratio of the Expenditure(as % of GDP) in East Asia (developing only) in 2004 to that in 2013?
Your answer should be very brief. 0.6. What is the ratio of the Expenditure(as % of GDP) of Upper middle income in 2004 to that in 2013?
Provide a short and direct response. 0.49. What is the ratio of the Expenditure(as % of GDP) of Georgia in 2004 to that in 2013?
Ensure brevity in your answer.  1.86. What is the ratio of the Expenditure(as % of GDP) in United Kingdom in 2004 to that in 2013?
Your answer should be compact. 0.99. What is the ratio of the Expenditure(as % of GDP) in East Asia (developing only) in 2005 to that in 2013?
Make the answer very short. 0.64. What is the ratio of the Expenditure(as % of GDP) of Upper middle income in 2005 to that in 2013?
Keep it short and to the point. 0.54. What is the ratio of the Expenditure(as % of GDP) in Georgia in 2005 to that in 2013?
Offer a very short reply. 1.34. What is the difference between the highest and the second highest Expenditure(as % of GDP) in East Asia (developing only)?
Offer a terse response. 0.66. What is the difference between the highest and the second highest Expenditure(as % of GDP) of Upper middle income?
Offer a terse response. 0.76. What is the difference between the highest and the second highest Expenditure(as % of GDP) of Georgia?
Offer a terse response. 0.01. What is the difference between the highest and the lowest Expenditure(as % of GDP) in East Asia (developing only)?
Offer a very short reply. 1.04. What is the difference between the highest and the lowest Expenditure(as % of GDP) in Upper middle income?
Keep it short and to the point. 0.95. What is the difference between the highest and the lowest Expenditure(as % of GDP) of Georgia?
Your answer should be very brief. 0.11. What is the difference between the highest and the lowest Expenditure(as % of GDP) in United Kingdom?
Make the answer very short. 0.11. 